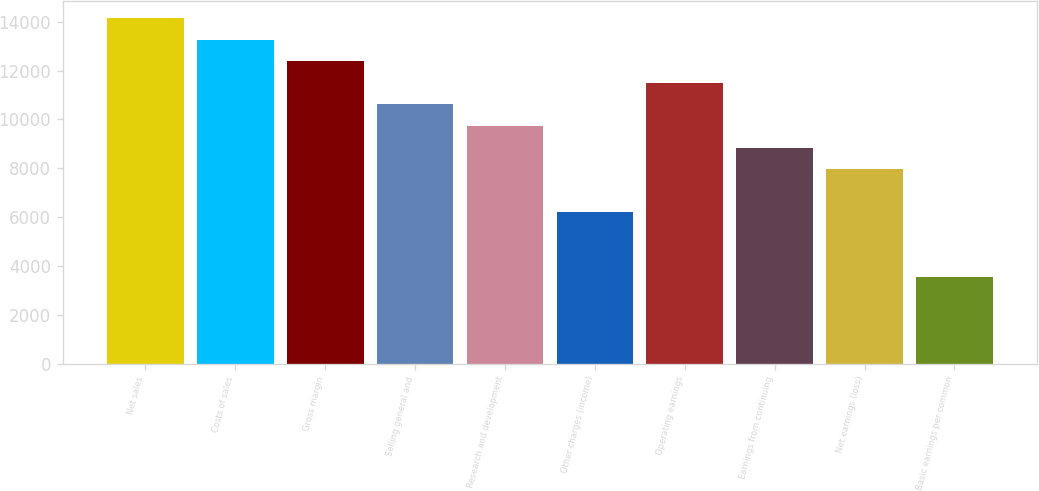Convert chart. <chart><loc_0><loc_0><loc_500><loc_500><bar_chart><fcel>Net sales<fcel>Costs of sales<fcel>Gross margin<fcel>Selling general and<fcel>Research and development<fcel>Other charges (income)<fcel>Operating earnings<fcel>Earnings from continuing<fcel>Net earnings (loss)<fcel>Basic earnings per common<nl><fcel>14147.2<fcel>13263<fcel>12378.8<fcel>10610.4<fcel>9726.24<fcel>6189.44<fcel>11494.6<fcel>8842.04<fcel>7957.84<fcel>3536.84<nl></chart> 